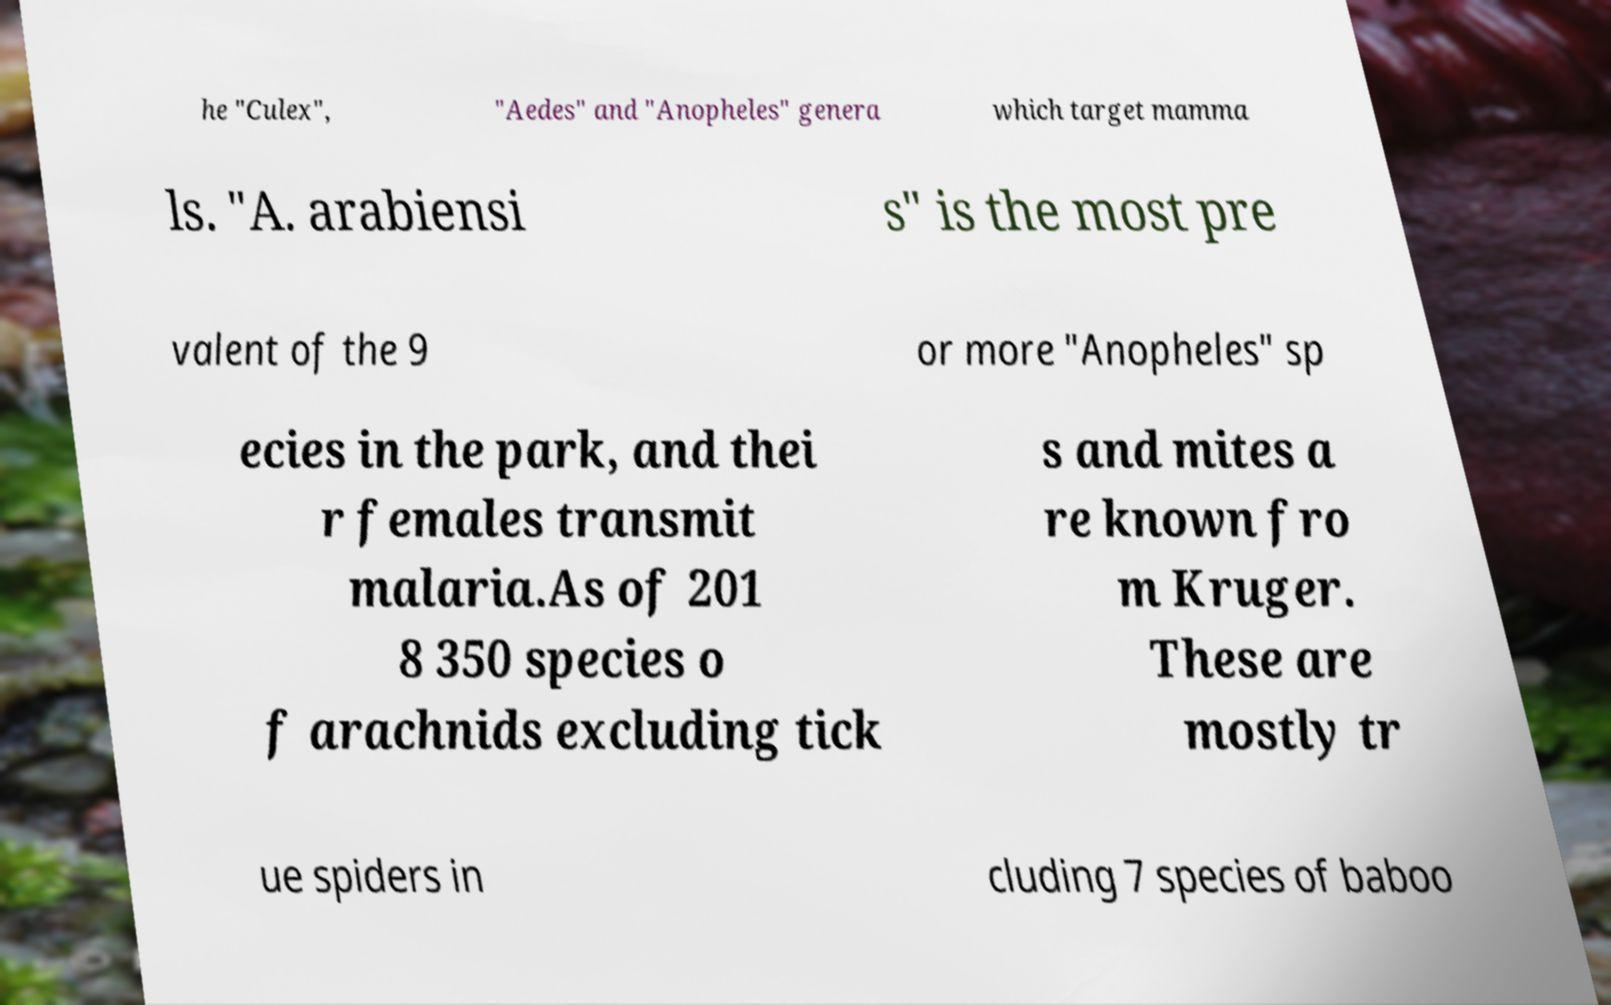Please read and relay the text visible in this image. What does it say? he "Culex", "Aedes" and "Anopheles" genera which target mamma ls. "A. arabiensi s" is the most pre valent of the 9 or more "Anopheles" sp ecies in the park, and thei r females transmit malaria.As of 201 8 350 species o f arachnids excluding tick s and mites a re known fro m Kruger. These are mostly tr ue spiders in cluding 7 species of baboo 